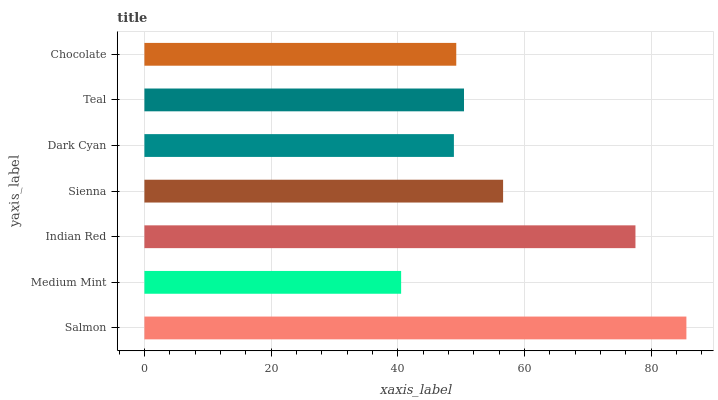Is Medium Mint the minimum?
Answer yes or no. Yes. Is Salmon the maximum?
Answer yes or no. Yes. Is Indian Red the minimum?
Answer yes or no. No. Is Indian Red the maximum?
Answer yes or no. No. Is Indian Red greater than Medium Mint?
Answer yes or no. Yes. Is Medium Mint less than Indian Red?
Answer yes or no. Yes. Is Medium Mint greater than Indian Red?
Answer yes or no. No. Is Indian Red less than Medium Mint?
Answer yes or no. No. Is Teal the high median?
Answer yes or no. Yes. Is Teal the low median?
Answer yes or no. Yes. Is Medium Mint the high median?
Answer yes or no. No. Is Salmon the low median?
Answer yes or no. No. 